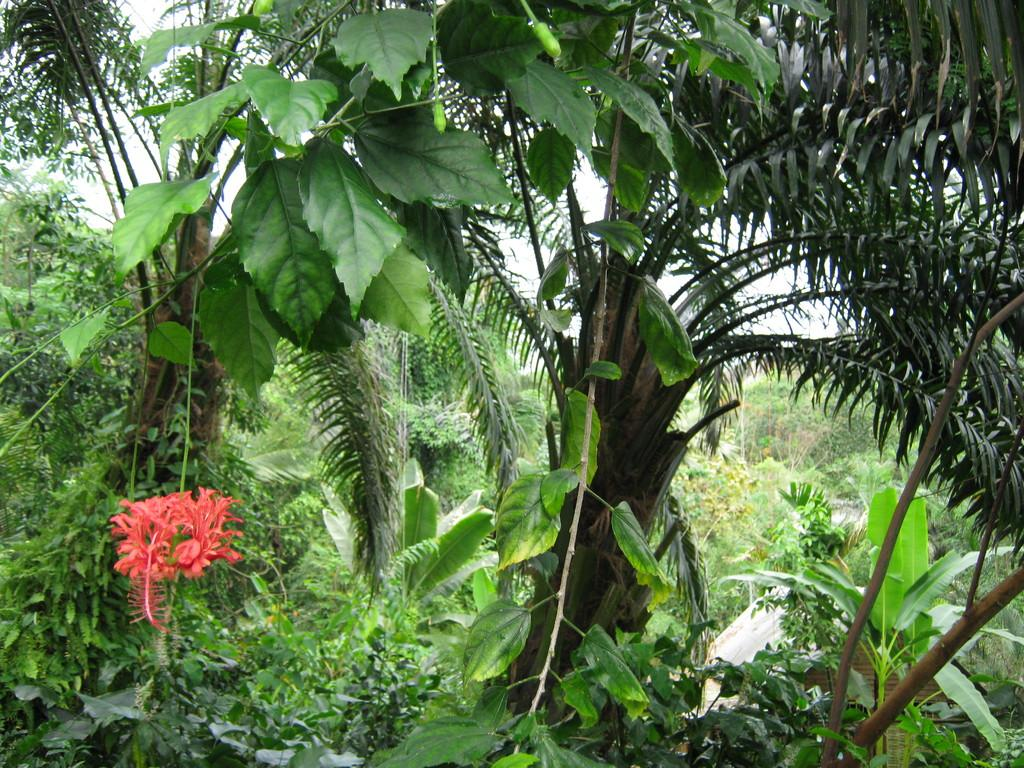What type of vegetation can be seen in the image? There are trees, plants, and flowers visible in the image. Are there any signs of growth or development in the image? Yes, buds are visible in the image. How many apples can be seen hanging from the trees in the image? There are no apples visible in the image; only trees, plants, flowers, and buds are present. Is there an owl perched on one of the branches in the image? There is no owl present in the image; only vegetation is visible. 